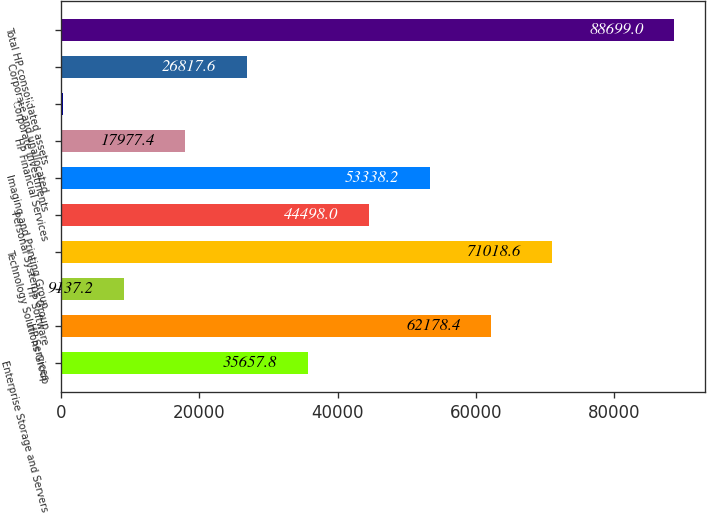Convert chart to OTSL. <chart><loc_0><loc_0><loc_500><loc_500><bar_chart><fcel>Enterprise Storage and Servers<fcel>HP Services<fcel>HP Software<fcel>Technology Solutions Group<fcel>Personal Systems Group<fcel>Imaging and Printing Group<fcel>HP Financial Services<fcel>Corporate Investments<fcel>Corporate and unallocated<fcel>Total HP consolidated assets<nl><fcel>35657.8<fcel>62178.4<fcel>9137.2<fcel>71018.6<fcel>44498<fcel>53338.2<fcel>17977.4<fcel>297<fcel>26817.6<fcel>88699<nl></chart> 